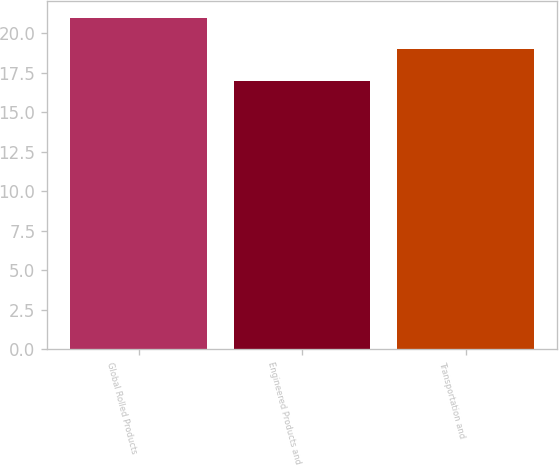Convert chart to OTSL. <chart><loc_0><loc_0><loc_500><loc_500><bar_chart><fcel>Global Rolled Products<fcel>Engineered Products and<fcel>Transportation and<nl><fcel>21<fcel>17<fcel>19<nl></chart> 